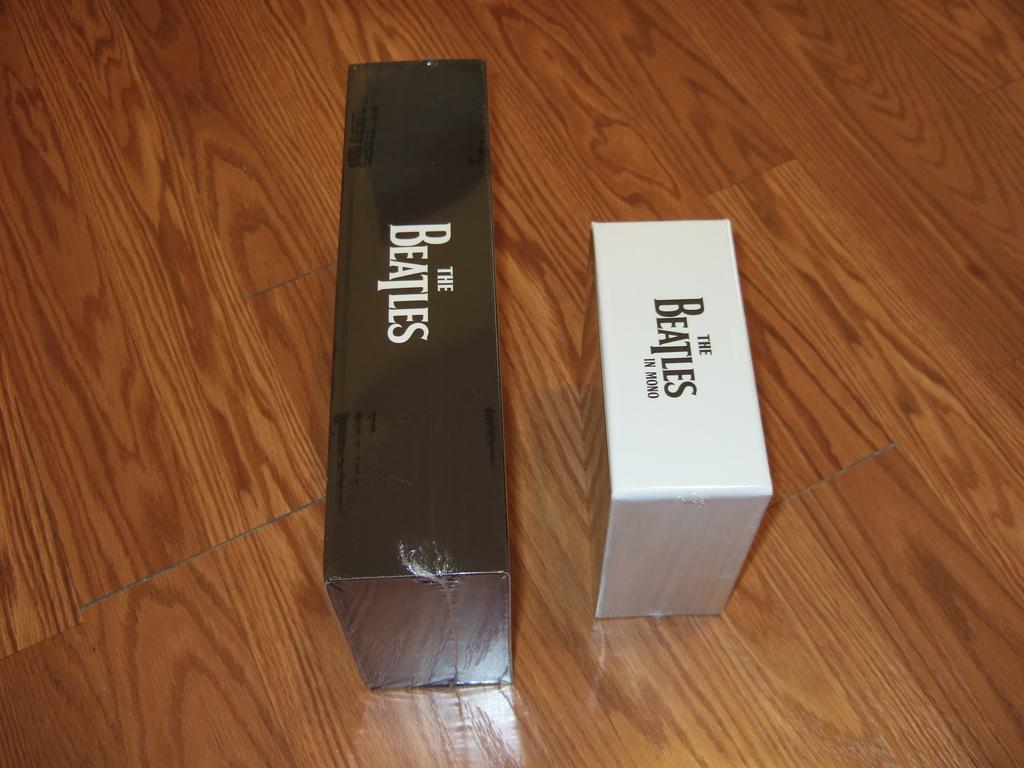<image>
Summarize the visual content of the image. A white box and a black box that contain The Beatles' recordings sitting on a wood surface 